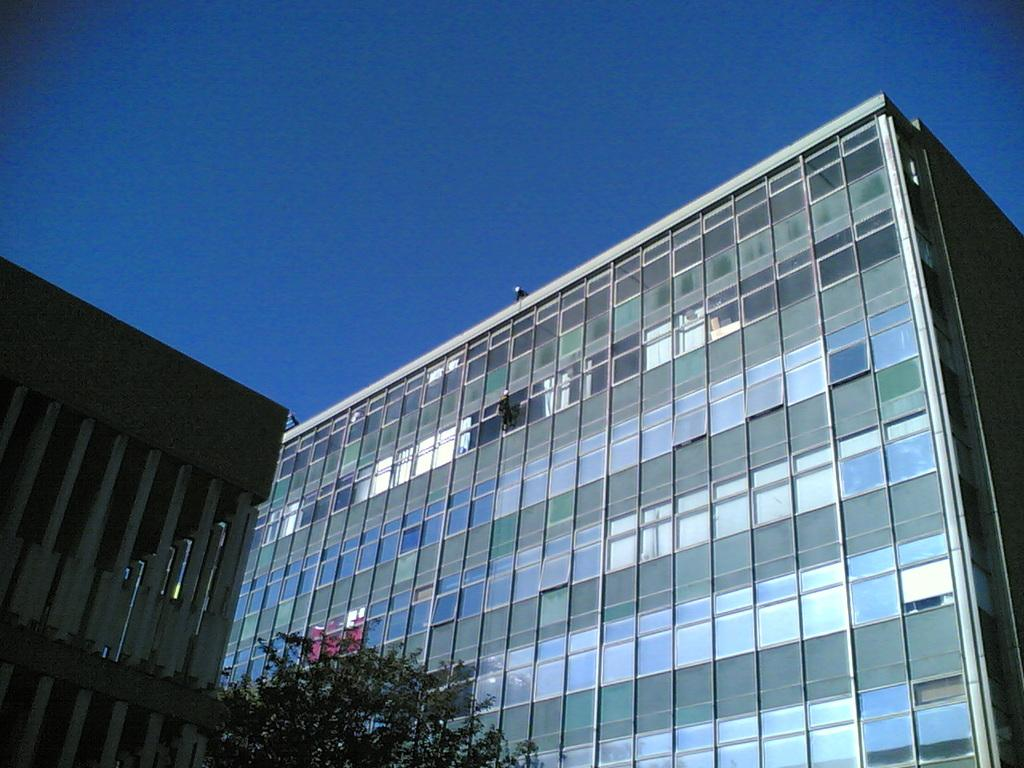What type of building can be seen on the left side of the image? There is a building with pillars on the left side of the image. Can you describe the other building in the image? There is another building with glass walls in the image. What natural element is present in the image? There is a tree in the image. What can be seen in the background of the image? The sky is visible in the background of the image. How many birds are sitting on the hole in the building? There is no hole or birds present in the image. What type of conversation is happening between the buildings in the image? Buildings do not have the ability to talk or engage in conversation, so there is no such activity depicted in the image. 